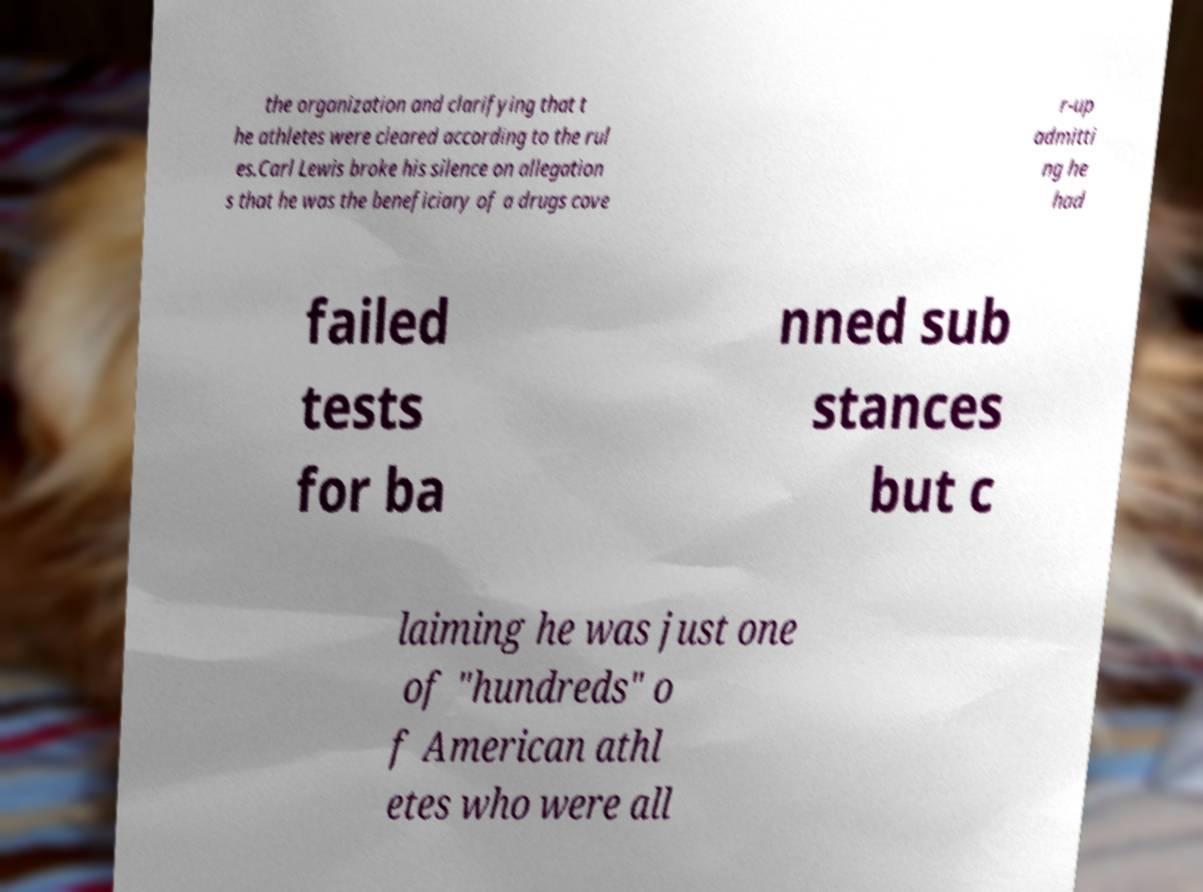What messages or text are displayed in this image? I need them in a readable, typed format. the organization and clarifying that t he athletes were cleared according to the rul es.Carl Lewis broke his silence on allegation s that he was the beneficiary of a drugs cove r-up admitti ng he had failed tests for ba nned sub stances but c laiming he was just one of "hundreds" o f American athl etes who were all 